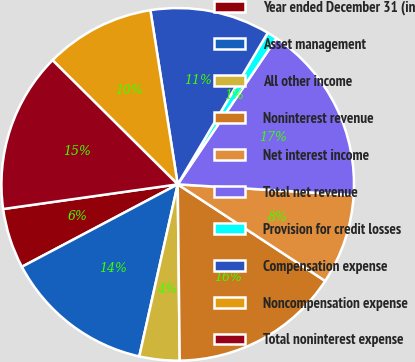Convert chart. <chart><loc_0><loc_0><loc_500><loc_500><pie_chart><fcel>Year ended December 31 (in<fcel>Asset management<fcel>All other income<fcel>Noninterest revenue<fcel>Net interest income<fcel>Total net revenue<fcel>Provision for credit losses<fcel>Compensation expense<fcel>Noncompensation expense<fcel>Total noninterest expense<nl><fcel>5.51%<fcel>13.76%<fcel>3.68%<fcel>15.59%<fcel>8.26%<fcel>16.51%<fcel>0.93%<fcel>11.01%<fcel>10.09%<fcel>14.67%<nl></chart> 